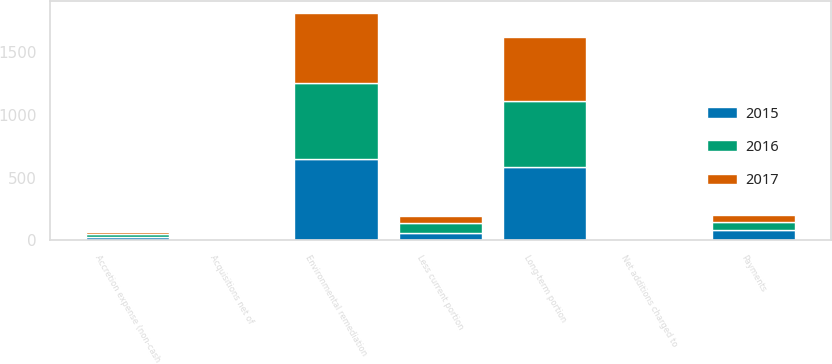Convert chart to OTSL. <chart><loc_0><loc_0><loc_500><loc_500><stacked_bar_chart><ecel><fcel>Environmental remediation<fcel>Net additions charged to<fcel>Payments<fcel>Accretion expense (non-cash<fcel>Acquisitions net of<fcel>Less current portion<fcel>Long-term portion<nl><fcel>2017<fcel>564<fcel>0.4<fcel>54.8<fcel>21<fcel>5.5<fcel>57.8<fcel>506.2<nl><fcel>2016<fcel>602.9<fcel>1.6<fcel>66.8<fcel>23.4<fcel>1.8<fcel>77.9<fcel>525<nl><fcel>2015<fcel>646.1<fcel>1.6<fcel>80<fcel>24.9<fcel>5.3<fcel>62.4<fcel>583.7<nl></chart> 